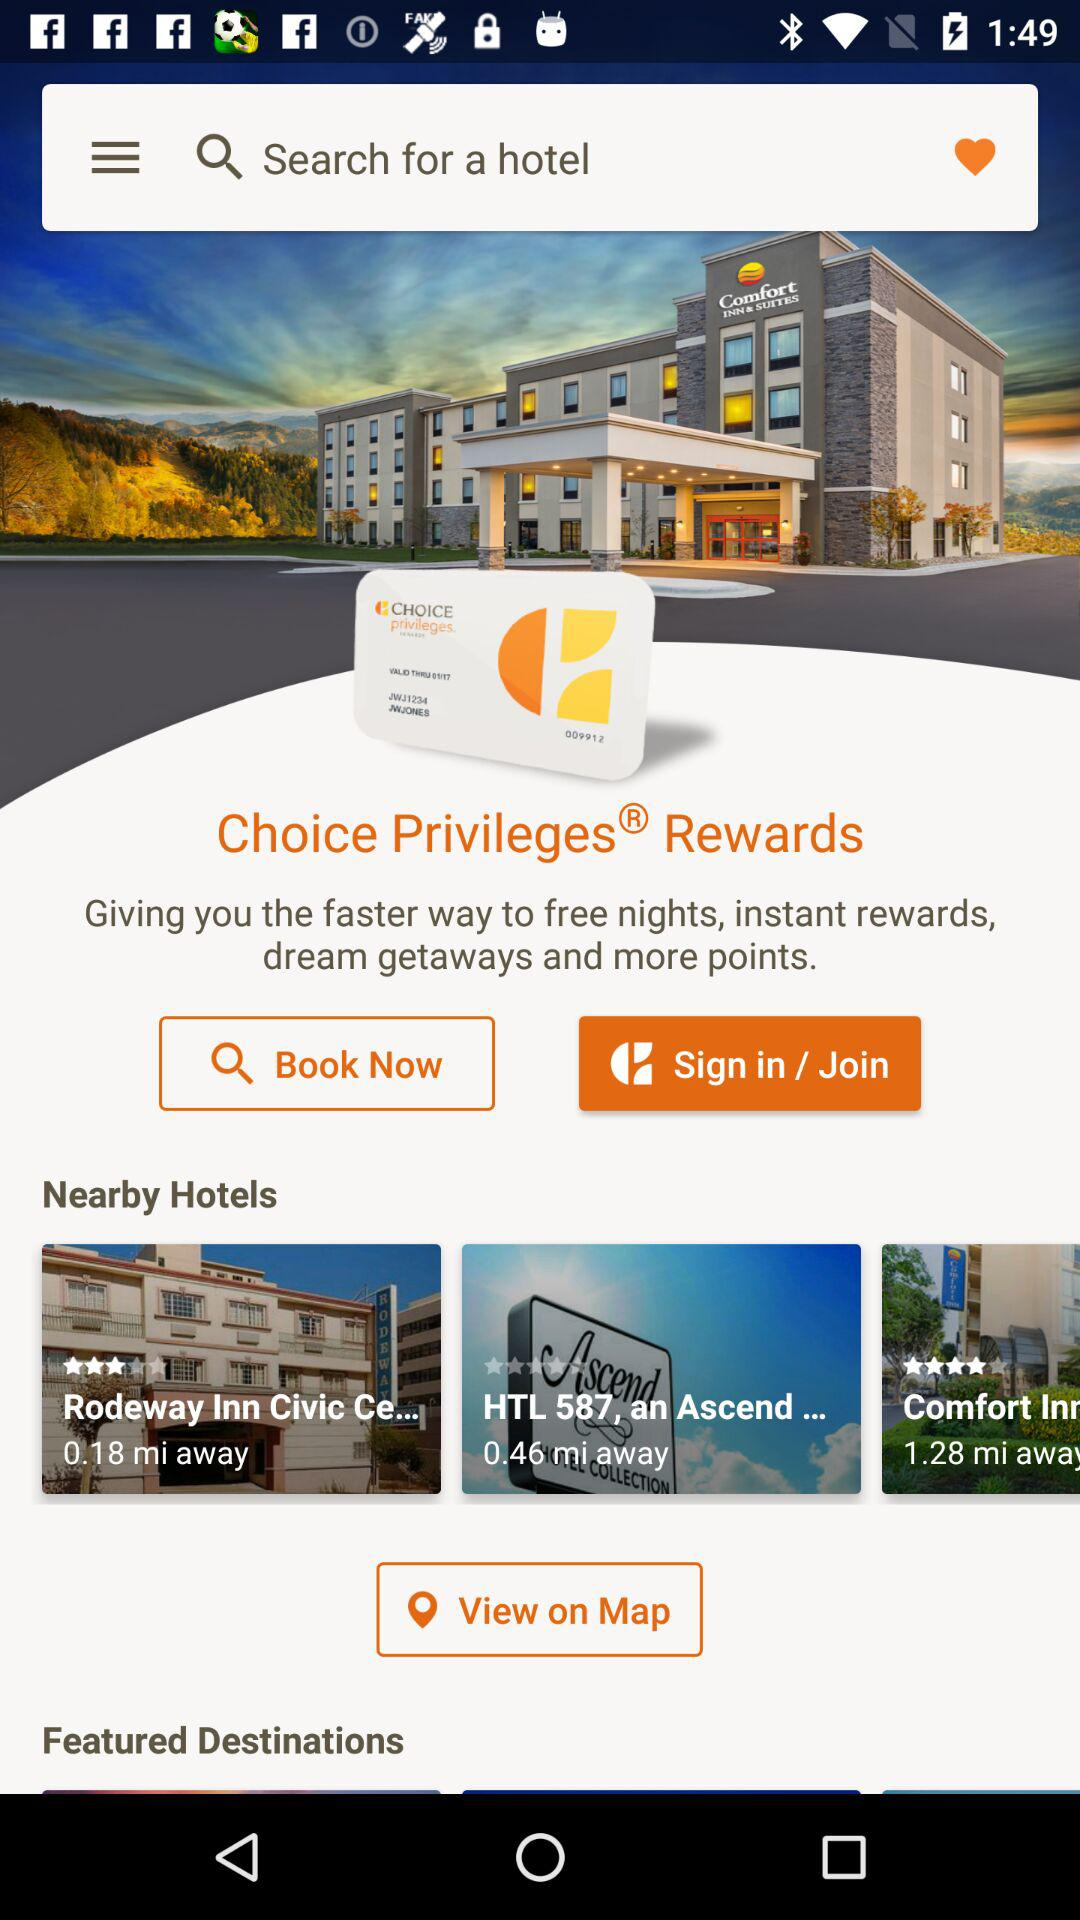How far is the "HTL" hotel from my location? The "HTL" hotel is 0.46 miles away. 